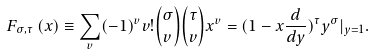Convert formula to latex. <formula><loc_0><loc_0><loc_500><loc_500>F _ { \sigma , \tau } \left ( x \right ) \equiv \sum _ { v } ( - 1 ) ^ { v } v ! { \binom { \sigma } { v } } { \binom { \tau } { v } } x ^ { v } = ( 1 - x { \frac { d } { d y } } ) ^ { \tau } y ^ { \sigma } | _ { y = 1 } .</formula> 